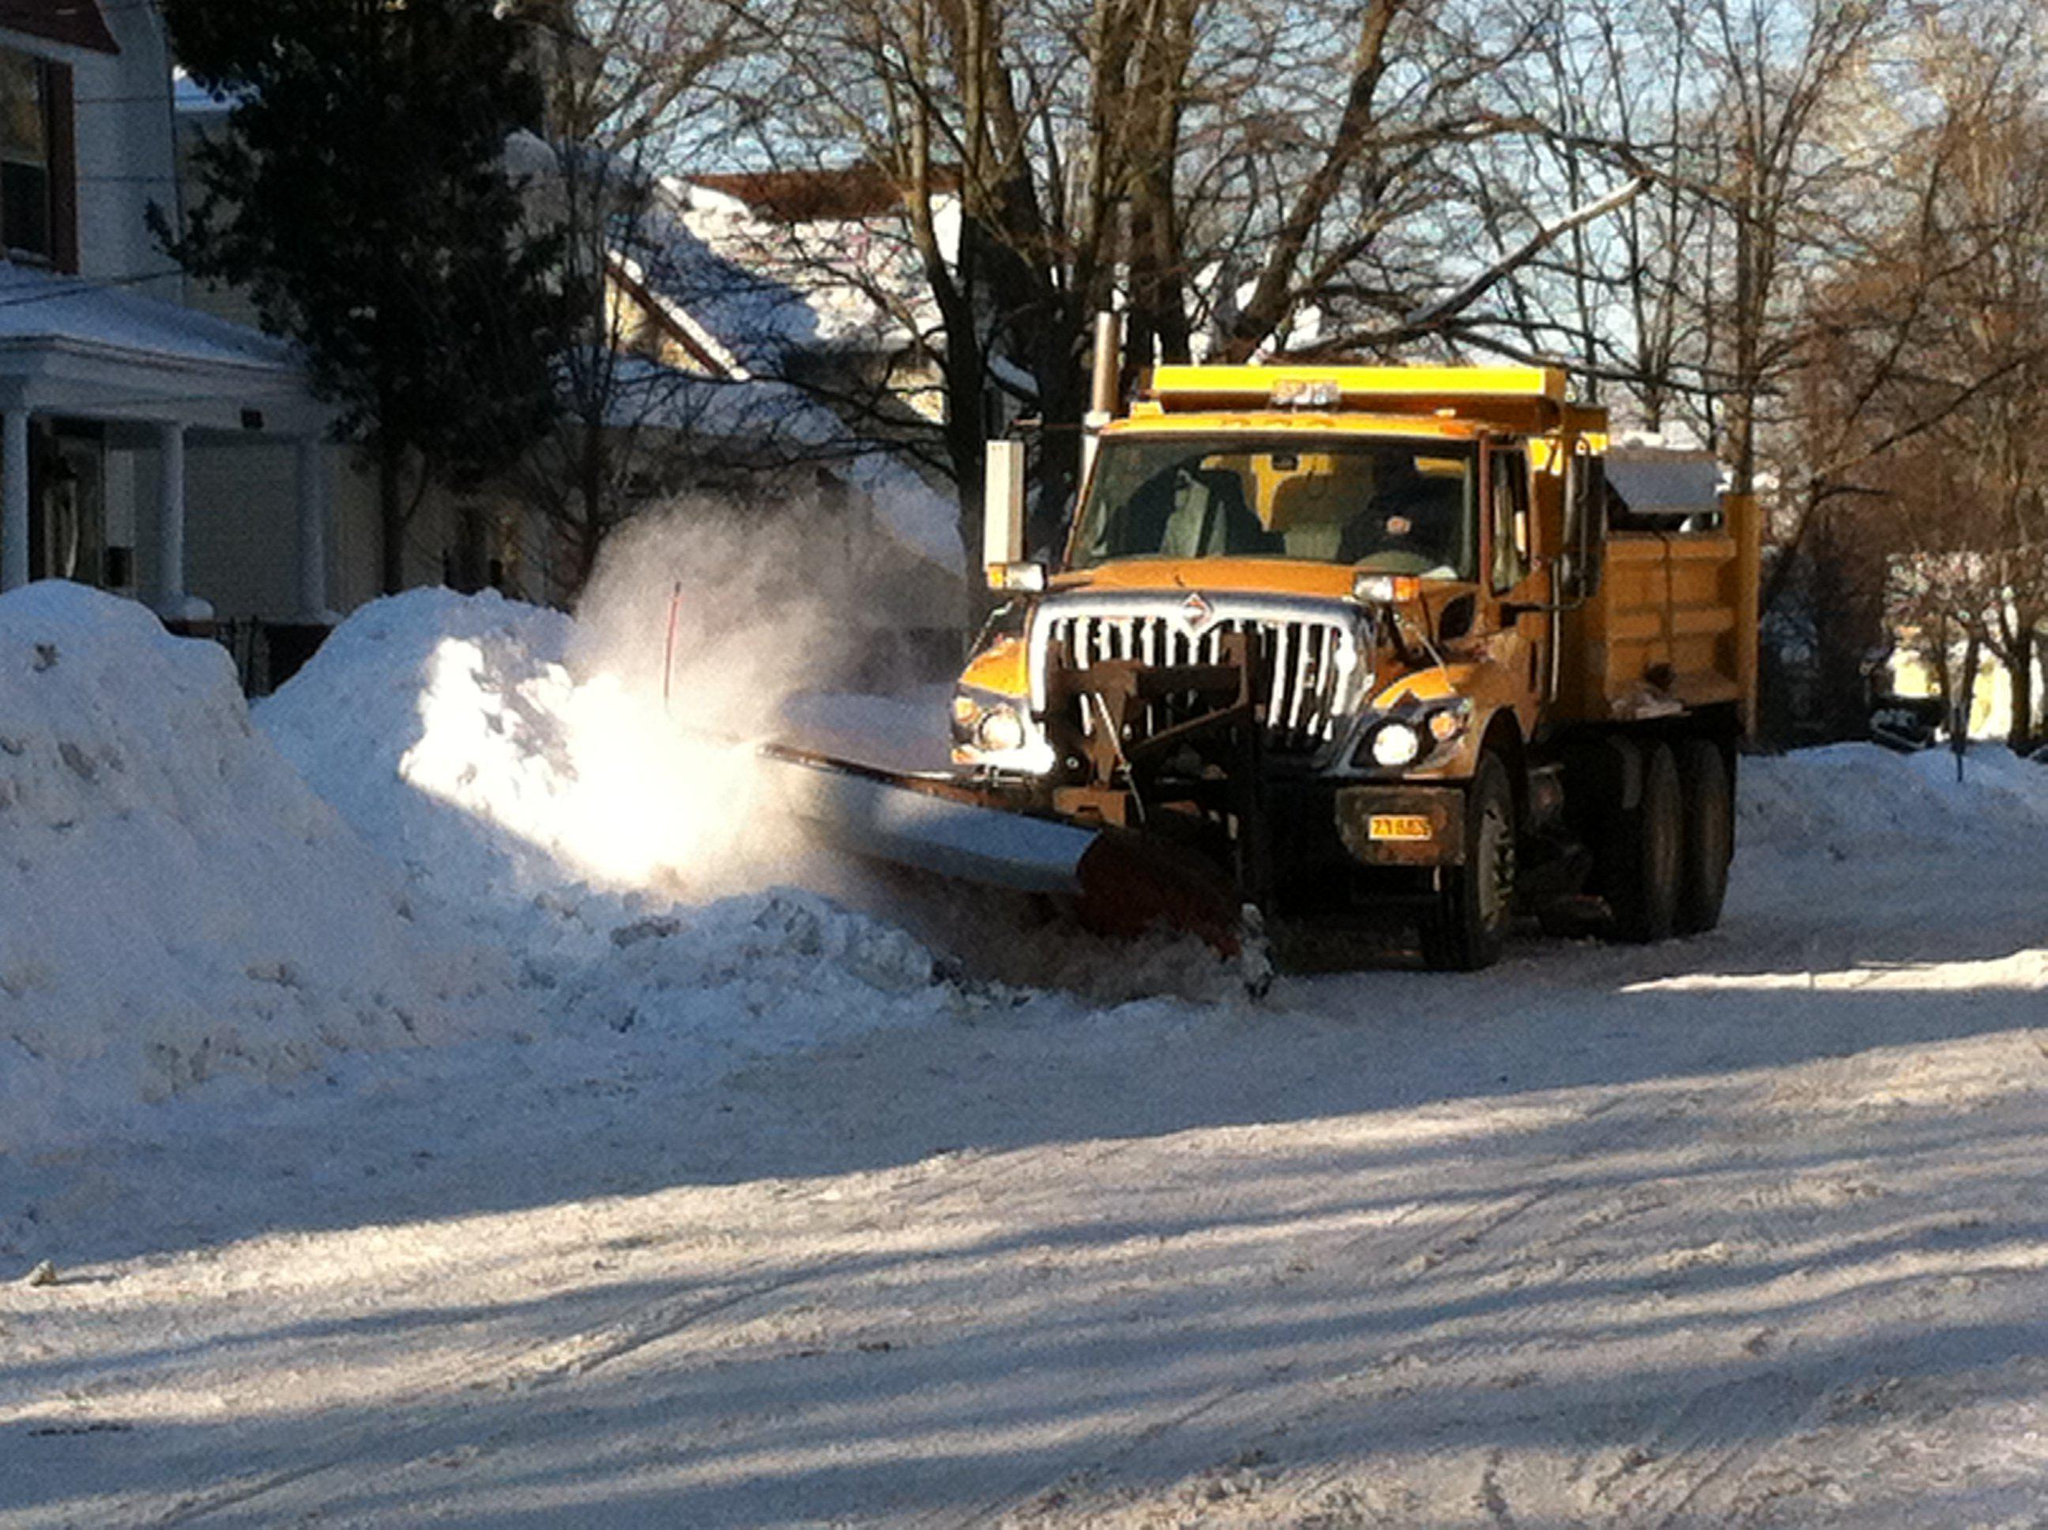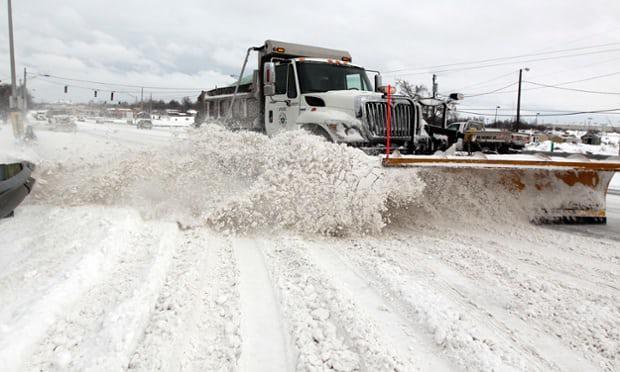The first image is the image on the left, the second image is the image on the right. Examine the images to the left and right. Is the description "The left and right image contains the same number of white and yellow snow plows." accurate? Answer yes or no. Yes. The first image is the image on the left, the second image is the image on the right. Given the left and right images, does the statement "Both plows are facing toward the bottom right and plowing snow." hold true? Answer yes or no. No. 